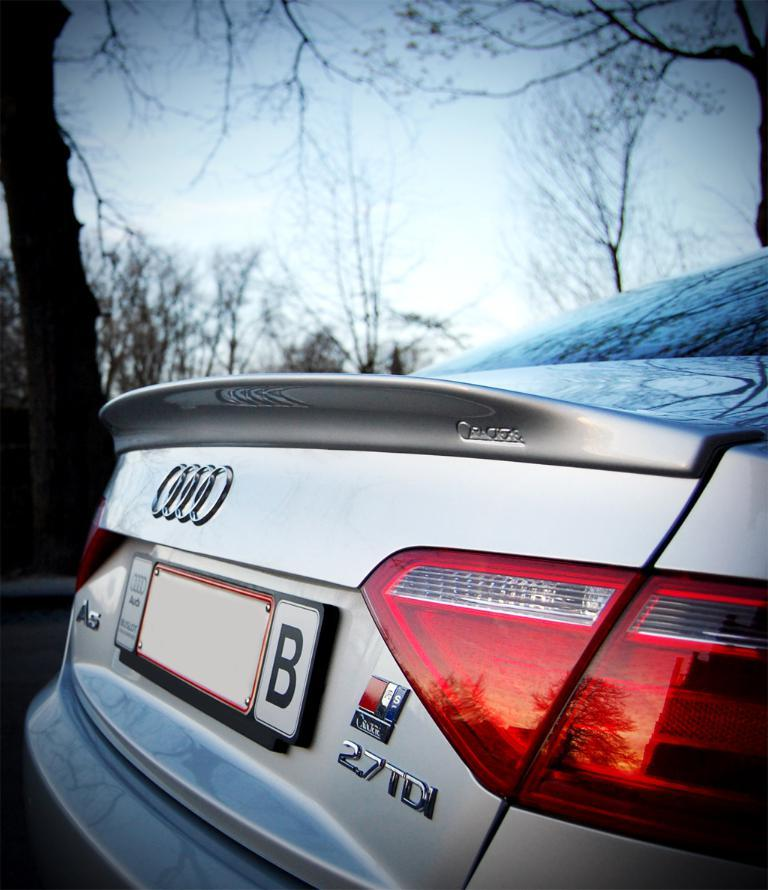<image>
Give a short and clear explanation of the subsequent image. An Audi 27TDI in silver, there is a B on the tag. 